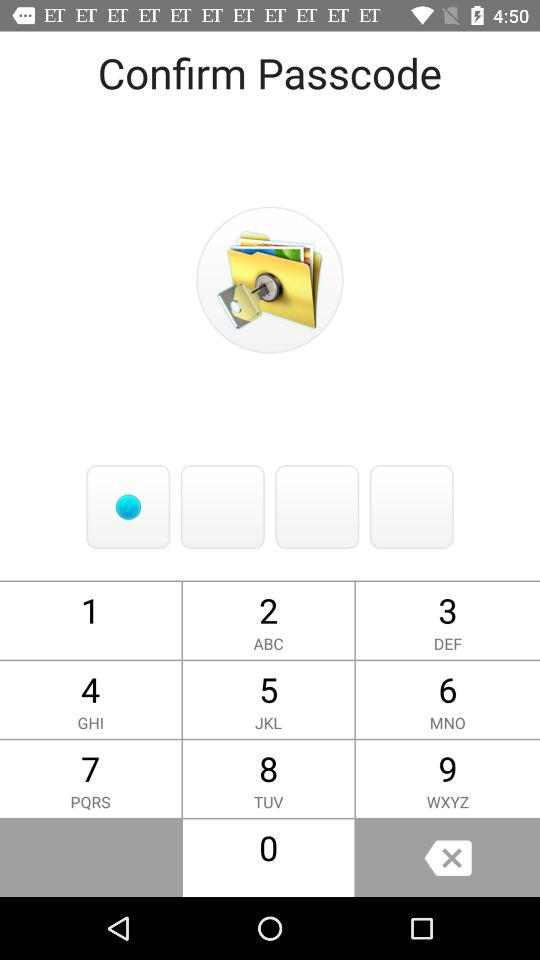How many white squares are there?
Answer the question using a single word or phrase. 4 